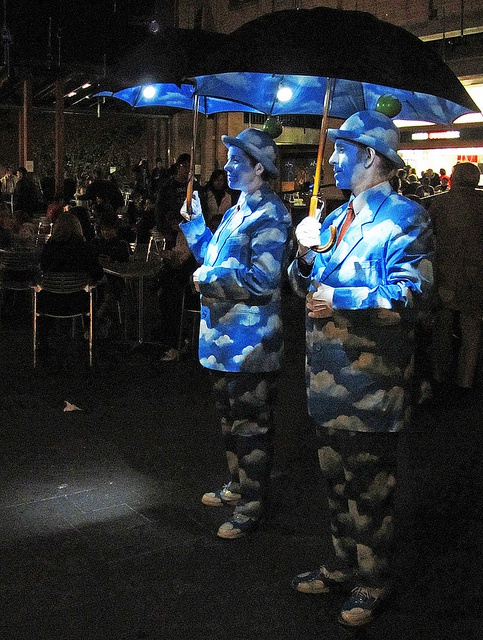Describe the objects in this image and their specific colors. I can see people in black, gray, white, and blue tones, people in black, navy, gray, and blue tones, umbrella in black, blue, and navy tones, people in black and gray tones, and umbrella in black, navy, blue, and darkblue tones in this image. 